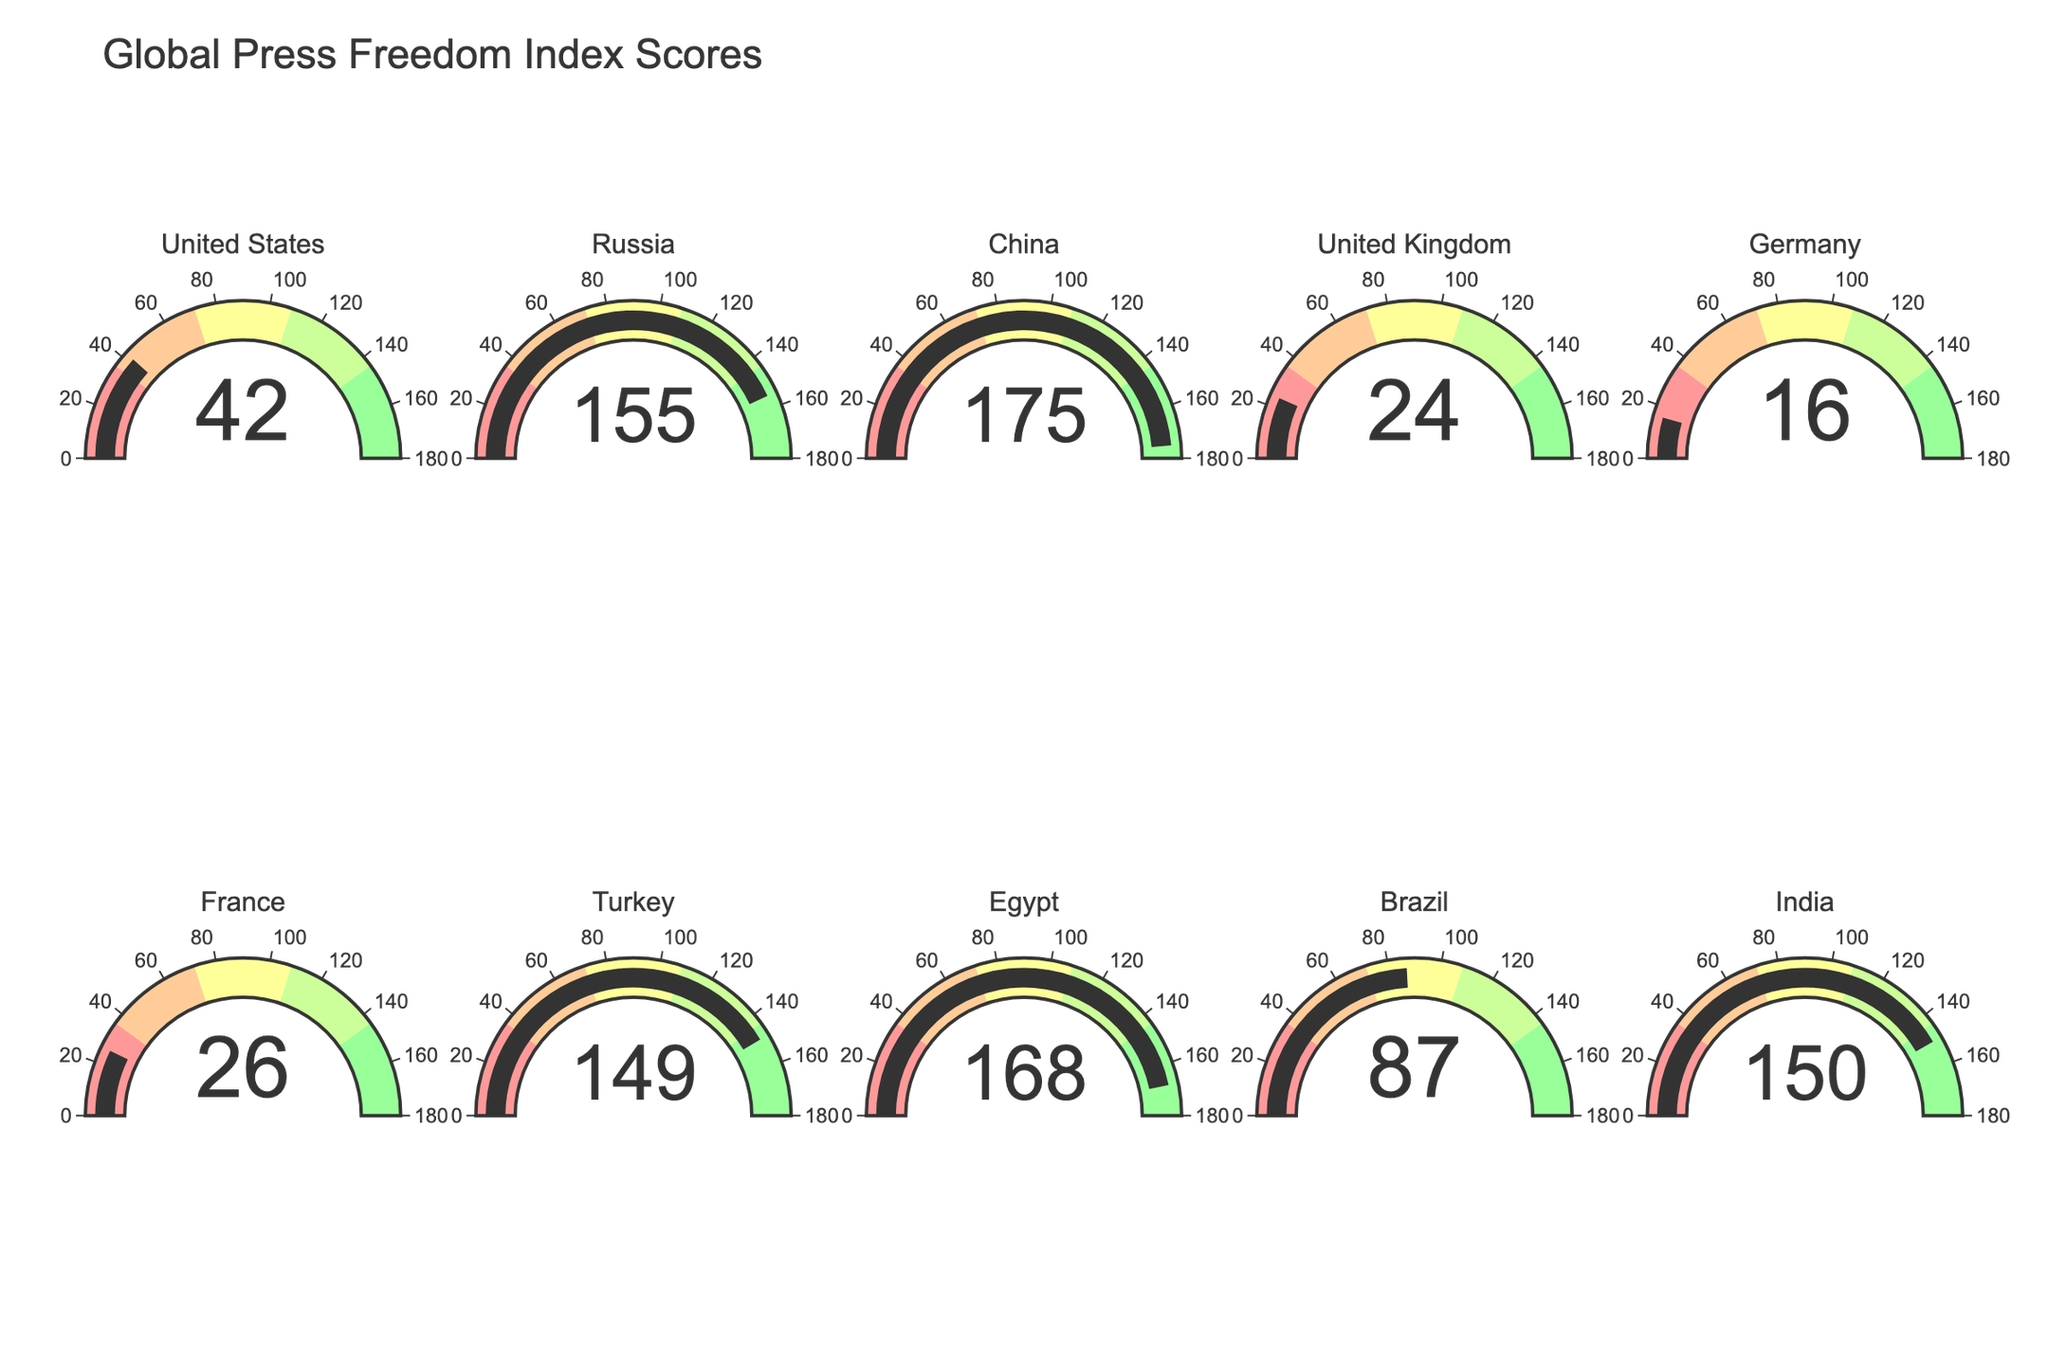Which country has the highest Press Freedom Index Score? The gauge chart shows scores for different countries. The highest score is indicated for China at 175.
Answer: China Which countries have a Press Freedom Index Score greater than 100? Observing the gauge charts, only China, Egypt, India, and Russia have scores above 100. Their scores are 175, 168, 150, and 155 respectively.
Answer: China, Egypt, India, Russia What is the range of Press Freedom Index Scores in the figure? The lowest score is for Germany at 16, and the highest score is for China at 175. Therefore, the range is 175 - 16.
Answer: 159 Which country has the lowest Press Freedom Index Score? By checking all the gauge charts, Germany has the lowest score of 16.
Answer: Germany What is the difference between the Press Freedom Index Scores of Brazil and Turkey? Brazil scores 87 and Turkey scores 149, thus the difference is 149 - 87.
Answer: 62 What is the average Press Freedom Index Score of the G7 countries (United States, United Kingdom, Germany, France)? Sum their scores (42 + 24 + 16 + 26) to get 108. Divide by the number of countries (4). 108/4 = 27
Answer: 27 How many countries have a Press Freedom Index Score below 50? The countries with scores below 50 are United States (42), United Kingdom (24), Germany (16), and France (26). There are 4 such countries.
Answer: 4 Compare the Press Freedom Index Scores of Russia and Egypt. Which country has a higher score? Russia has a score of 155 while Egypt has a score of 168, so Egypt has a higher score.
Answer: Egypt What is the total Press Freedom Index Score of United Kingdom, France, and Turkey combined? The scores are United Kingdom (24), France (26), and Turkey (149). The total is 24 + 26 + 149 = 199.
Answer: 199 List the countries whose Press Freedom Index Scores fall in the range 50-100. Brazil is the only country with a score of 87 that falls within this range.
Answer: Brazil 